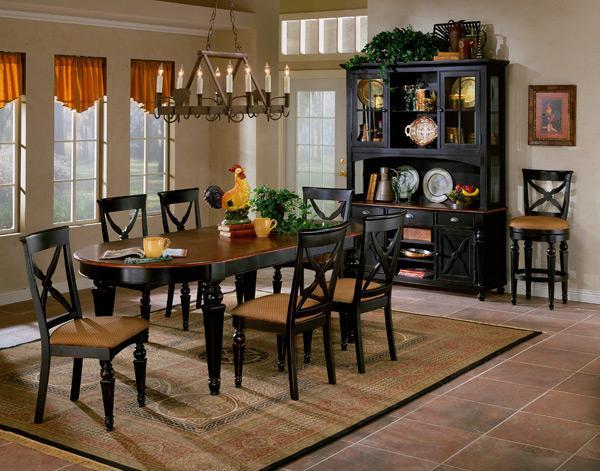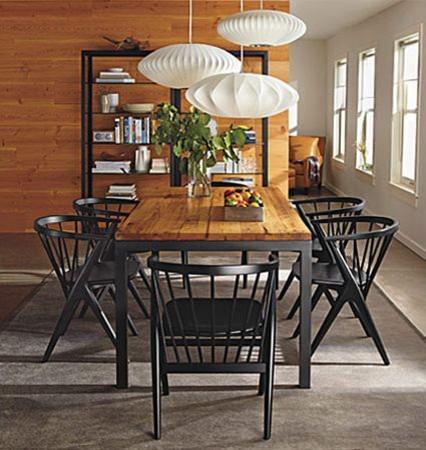The first image is the image on the left, the second image is the image on the right. Analyze the images presented: Is the assertion "There are three windows on the left wall in the image on the left." valid? Answer yes or no. Yes. 